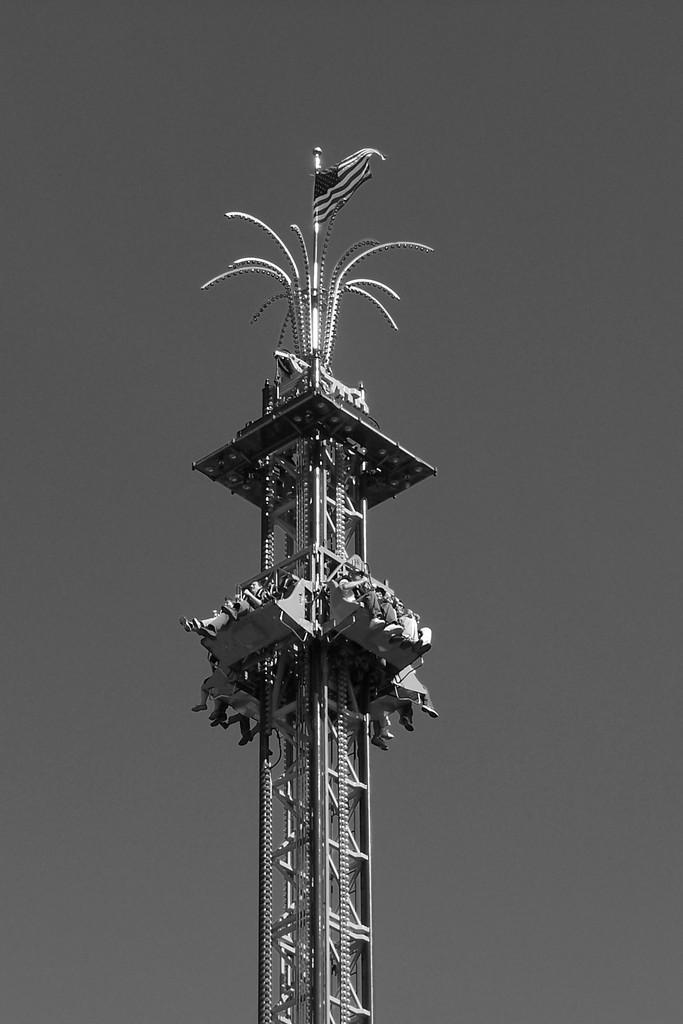What is the color scheme of the image? The image is black and white. What can be seen in the image besides the color scheme? There are many people sitting on a drop tower. What is at the top of the drop tower? There is a flag at the top of the drop tower. What invention is being demonstrated by the people in the image? There is no invention being demonstrated in the image; it simply shows people sitting on a drop tower with a flag at the top. What appliance is being used by the people in the image? There is no appliance being used by the people in the image; they are simply sitting on a drop tower. 